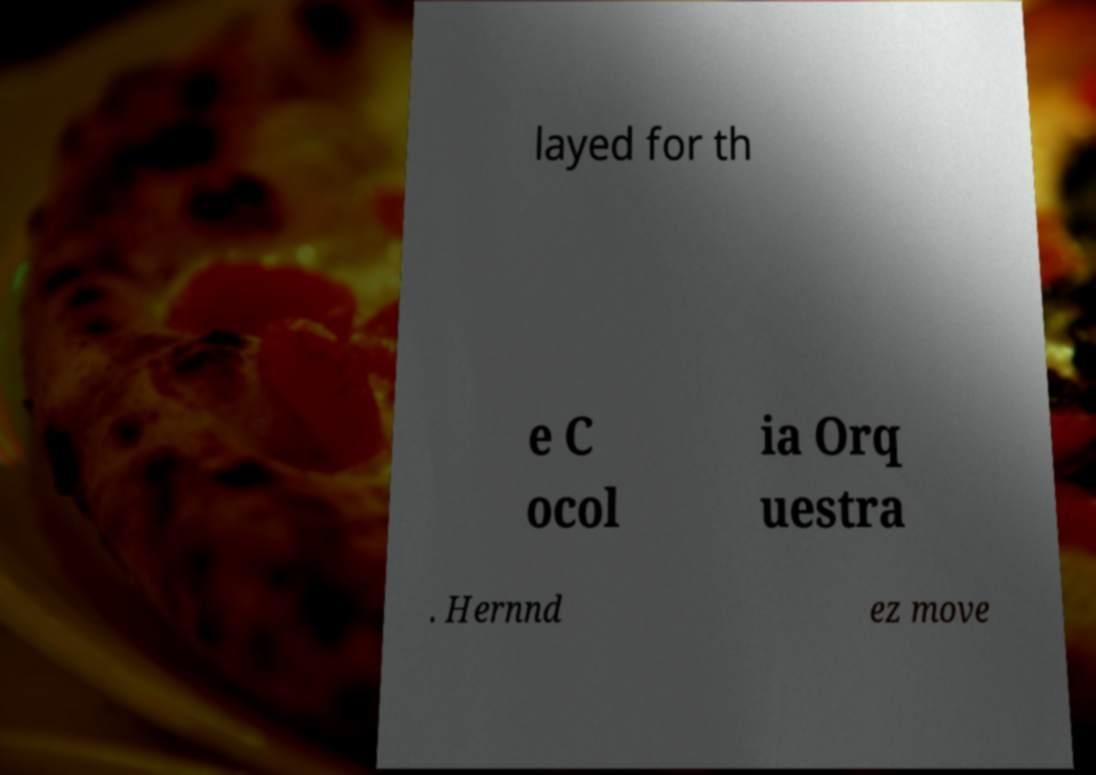What messages or text are displayed in this image? I need them in a readable, typed format. layed for th e C ocol ia Orq uestra . Hernnd ez move 